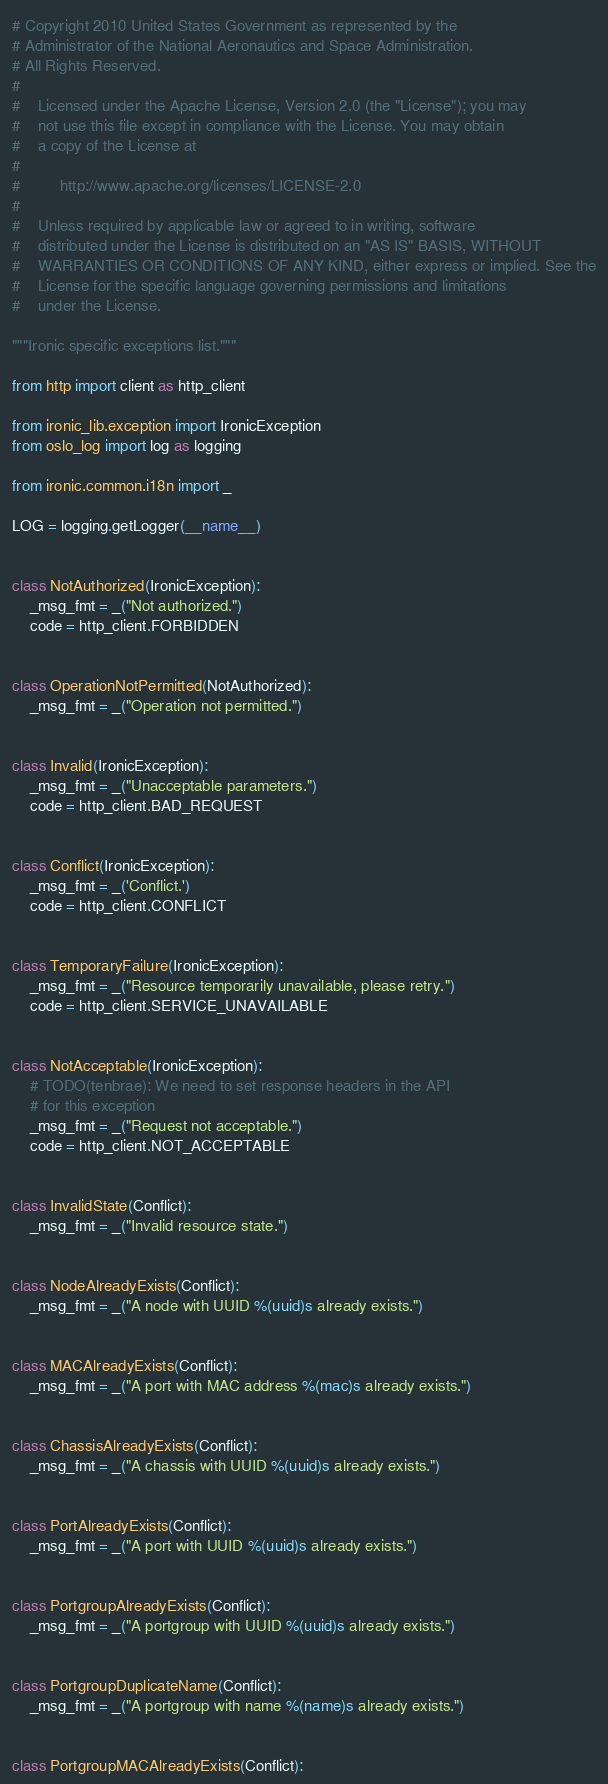<code> <loc_0><loc_0><loc_500><loc_500><_Python_># Copyright 2010 United States Government as represented by the
# Administrator of the National Aeronautics and Space Administration.
# All Rights Reserved.
#
#    Licensed under the Apache License, Version 2.0 (the "License"); you may
#    not use this file except in compliance with the License. You may obtain
#    a copy of the License at
#
#         http://www.apache.org/licenses/LICENSE-2.0
#
#    Unless required by applicable law or agreed to in writing, software
#    distributed under the License is distributed on an "AS IS" BASIS, WITHOUT
#    WARRANTIES OR CONDITIONS OF ANY KIND, either express or implied. See the
#    License for the specific language governing permissions and limitations
#    under the License.

"""Ironic specific exceptions list."""

from http import client as http_client

from ironic_lib.exception import IronicException
from oslo_log import log as logging

from ironic.common.i18n import _

LOG = logging.getLogger(__name__)


class NotAuthorized(IronicException):
    _msg_fmt = _("Not authorized.")
    code = http_client.FORBIDDEN


class OperationNotPermitted(NotAuthorized):
    _msg_fmt = _("Operation not permitted.")


class Invalid(IronicException):
    _msg_fmt = _("Unacceptable parameters.")
    code = http_client.BAD_REQUEST


class Conflict(IronicException):
    _msg_fmt = _('Conflict.')
    code = http_client.CONFLICT


class TemporaryFailure(IronicException):
    _msg_fmt = _("Resource temporarily unavailable, please retry.")
    code = http_client.SERVICE_UNAVAILABLE


class NotAcceptable(IronicException):
    # TODO(tenbrae): We need to set response headers in the API
    # for this exception
    _msg_fmt = _("Request not acceptable.")
    code = http_client.NOT_ACCEPTABLE


class InvalidState(Conflict):
    _msg_fmt = _("Invalid resource state.")


class NodeAlreadyExists(Conflict):
    _msg_fmt = _("A node with UUID %(uuid)s already exists.")


class MACAlreadyExists(Conflict):
    _msg_fmt = _("A port with MAC address %(mac)s already exists.")


class ChassisAlreadyExists(Conflict):
    _msg_fmt = _("A chassis with UUID %(uuid)s already exists.")


class PortAlreadyExists(Conflict):
    _msg_fmt = _("A port with UUID %(uuid)s already exists.")


class PortgroupAlreadyExists(Conflict):
    _msg_fmt = _("A portgroup with UUID %(uuid)s already exists.")


class PortgroupDuplicateName(Conflict):
    _msg_fmt = _("A portgroup with name %(name)s already exists.")


class PortgroupMACAlreadyExists(Conflict):</code> 